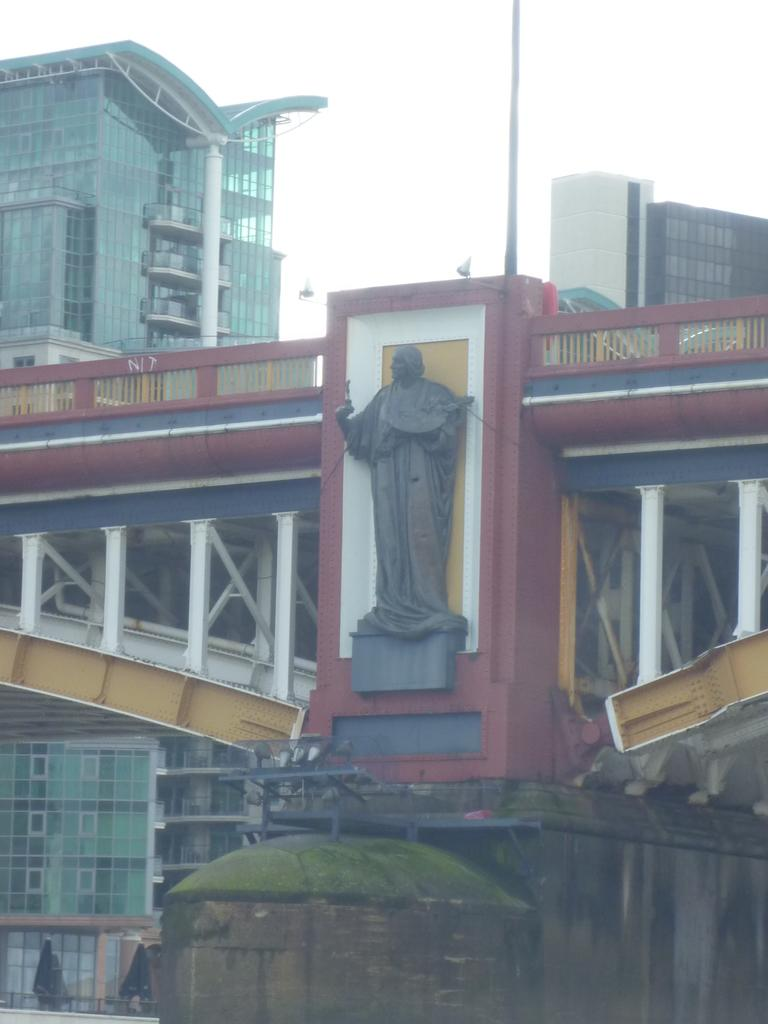What type of structures can be seen in the image? There are buildings in the image. What type of man-made feature is present in the image that connects two areas? There is a bridge in the image. What type of artwork or monument is present in the image? There is a statue in the image. How would you describe the sky in the image? The sky is cloudy in the image. What type of ring can be seen on the statue's finger in the image? There is no ring visible on the statue's finger in the image. What type of tramp is performing on the bridge in the image? There is no tramp performing on the bridge in the image. 